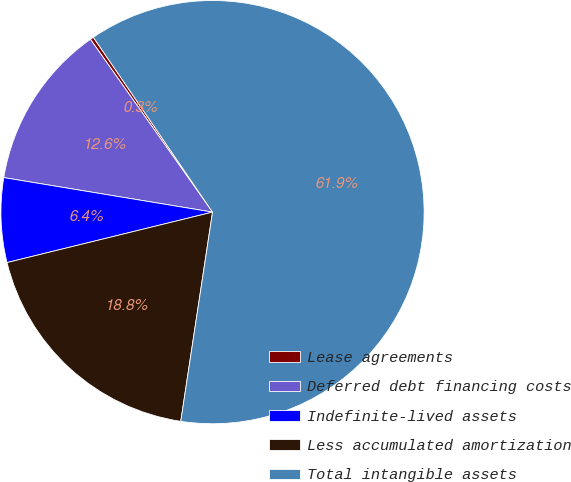Convert chart. <chart><loc_0><loc_0><loc_500><loc_500><pie_chart><fcel>Lease agreements<fcel>Deferred debt financing costs<fcel>Indefinite-lived assets<fcel>Less accumulated amortization<fcel>Total intangible assets<nl><fcel>0.27%<fcel>12.6%<fcel>6.44%<fcel>18.77%<fcel>61.92%<nl></chart> 